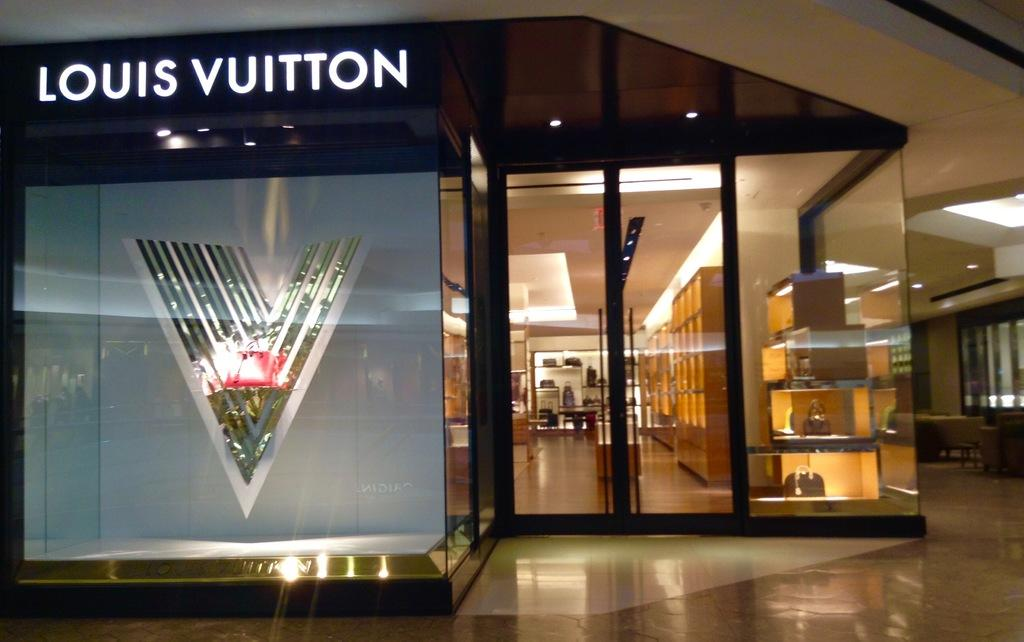<image>
Render a clear and concise summary of the photo. Store entrance to Louis Vuitton with a V on the shaded window. 